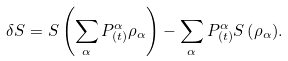Convert formula to latex. <formula><loc_0><loc_0><loc_500><loc_500>\delta S = S \left ( \sum _ { \alpha } { P ^ { \alpha } _ { ( t ) } \rho _ { \alpha } } \right ) - \sum _ { \alpha } { P ^ { \alpha } _ { ( t ) } S \left ( \rho _ { \alpha } \right ) } .</formula> 